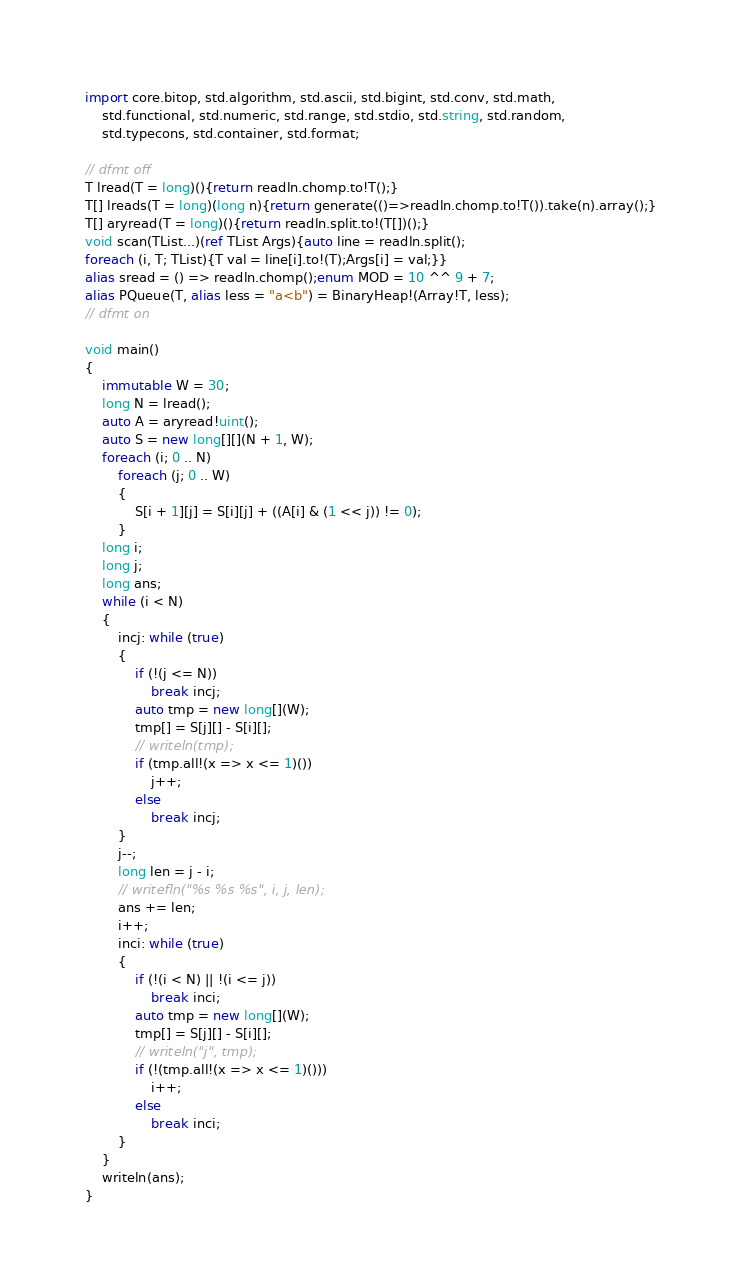<code> <loc_0><loc_0><loc_500><loc_500><_D_>import core.bitop, std.algorithm, std.ascii, std.bigint, std.conv, std.math,
    std.functional, std.numeric, std.range, std.stdio, std.string, std.random,
    std.typecons, std.container, std.format;

// dfmt off
T lread(T = long)(){return readln.chomp.to!T();}
T[] lreads(T = long)(long n){return generate(()=>readln.chomp.to!T()).take(n).array();}
T[] aryread(T = long)(){return readln.split.to!(T[])();}
void scan(TList...)(ref TList Args){auto line = readln.split();
foreach (i, T; TList){T val = line[i].to!(T);Args[i] = val;}}
alias sread = () => readln.chomp();enum MOD = 10 ^^ 9 + 7;
alias PQueue(T, alias less = "a<b") = BinaryHeap!(Array!T, less);
// dfmt on

void main()
{
    immutable W = 30;
    long N = lread();
    auto A = aryread!uint();
    auto S = new long[][](N + 1, W);
    foreach (i; 0 .. N)
        foreach (j; 0 .. W)
        {
            S[i + 1][j] = S[i][j] + ((A[i] & (1 << j)) != 0);
        }
    long i;
    long j;
    long ans;
    while (i < N)
    {
        incj: while (true)
        {
            if (!(j <= N))
                break incj;
            auto tmp = new long[](W);
            tmp[] = S[j][] - S[i][];
            // writeln(tmp);
            if (tmp.all!(x => x <= 1)())
                j++;
            else
                break incj;
        }
        j--;
        long len = j - i;
        // writefln("%s %s %s", i, j, len);
        ans += len;
        i++;
        inci: while (true)
        {
            if (!(i < N) || !(i <= j))
                break inci;
            auto tmp = new long[](W);
            tmp[] = S[j][] - S[i][];
            // writeln("j", tmp);
            if (!(tmp.all!(x => x <= 1)()))
                i++;
            else
                break inci;
        }
    }
    writeln(ans);
}
</code> 